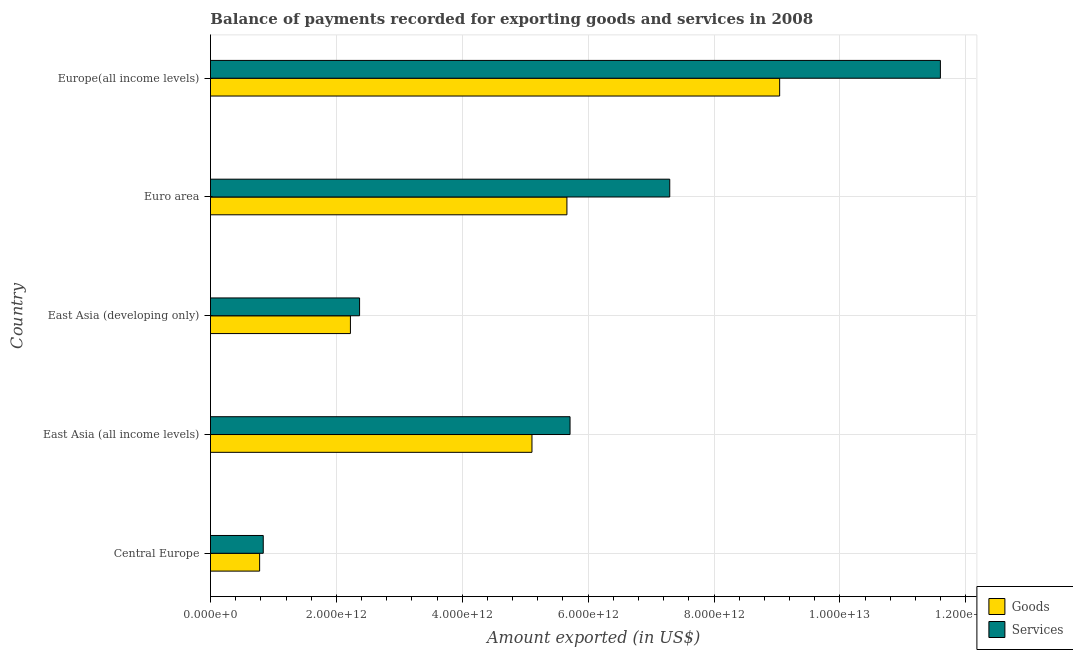How many different coloured bars are there?
Offer a very short reply. 2. Are the number of bars per tick equal to the number of legend labels?
Ensure brevity in your answer.  Yes. Are the number of bars on each tick of the Y-axis equal?
Ensure brevity in your answer.  Yes. How many bars are there on the 5th tick from the top?
Give a very brief answer. 2. How many bars are there on the 5th tick from the bottom?
Provide a short and direct response. 2. What is the label of the 3rd group of bars from the top?
Make the answer very short. East Asia (developing only). In how many cases, is the number of bars for a given country not equal to the number of legend labels?
Provide a short and direct response. 0. What is the amount of goods exported in Central Europe?
Your answer should be compact. 7.81e+11. Across all countries, what is the maximum amount of services exported?
Offer a very short reply. 1.16e+13. Across all countries, what is the minimum amount of services exported?
Offer a very short reply. 8.38e+11. In which country was the amount of goods exported maximum?
Offer a terse response. Europe(all income levels). In which country was the amount of goods exported minimum?
Give a very brief answer. Central Europe. What is the total amount of goods exported in the graph?
Offer a terse response. 2.28e+13. What is the difference between the amount of goods exported in East Asia (all income levels) and that in Euro area?
Keep it short and to the point. -5.55e+11. What is the difference between the amount of services exported in East Asia (all income levels) and the amount of goods exported in East Asia (developing only)?
Provide a short and direct response. 3.49e+12. What is the average amount of goods exported per country?
Provide a succinct answer. 4.56e+12. What is the difference between the amount of goods exported and amount of services exported in East Asia (all income levels)?
Offer a very short reply. -6.05e+11. What is the ratio of the amount of services exported in Central Europe to that in East Asia (all income levels)?
Make the answer very short. 0.15. Is the amount of goods exported in East Asia (developing only) less than that in Europe(all income levels)?
Keep it short and to the point. Yes. Is the difference between the amount of services exported in Central Europe and East Asia (developing only) greater than the difference between the amount of goods exported in Central Europe and East Asia (developing only)?
Your answer should be compact. No. What is the difference between the highest and the second highest amount of services exported?
Your answer should be very brief. 4.30e+12. What is the difference between the highest and the lowest amount of services exported?
Your answer should be compact. 1.08e+13. Is the sum of the amount of goods exported in East Asia (developing only) and Europe(all income levels) greater than the maximum amount of services exported across all countries?
Your answer should be very brief. No. What does the 1st bar from the top in Euro area represents?
Provide a short and direct response. Services. What does the 1st bar from the bottom in East Asia (all income levels) represents?
Offer a terse response. Goods. How many countries are there in the graph?
Your response must be concise. 5. What is the difference between two consecutive major ticks on the X-axis?
Offer a terse response. 2.00e+12. Does the graph contain grids?
Provide a succinct answer. Yes. How are the legend labels stacked?
Give a very brief answer. Vertical. What is the title of the graph?
Your response must be concise. Balance of payments recorded for exporting goods and services in 2008. Does "Methane emissions" appear as one of the legend labels in the graph?
Your response must be concise. No. What is the label or title of the X-axis?
Offer a very short reply. Amount exported (in US$). What is the Amount exported (in US$) in Goods in Central Europe?
Keep it short and to the point. 7.81e+11. What is the Amount exported (in US$) in Services in Central Europe?
Offer a terse response. 8.38e+11. What is the Amount exported (in US$) in Goods in East Asia (all income levels)?
Keep it short and to the point. 5.11e+12. What is the Amount exported (in US$) in Services in East Asia (all income levels)?
Your answer should be very brief. 5.71e+12. What is the Amount exported (in US$) in Goods in East Asia (developing only)?
Keep it short and to the point. 2.22e+12. What is the Amount exported (in US$) in Services in East Asia (developing only)?
Offer a terse response. 2.37e+12. What is the Amount exported (in US$) in Goods in Euro area?
Your answer should be very brief. 5.66e+12. What is the Amount exported (in US$) of Services in Euro area?
Offer a very short reply. 7.30e+12. What is the Amount exported (in US$) of Goods in Europe(all income levels)?
Your response must be concise. 9.04e+12. What is the Amount exported (in US$) of Services in Europe(all income levels)?
Make the answer very short. 1.16e+13. Across all countries, what is the maximum Amount exported (in US$) in Goods?
Ensure brevity in your answer.  9.04e+12. Across all countries, what is the maximum Amount exported (in US$) in Services?
Keep it short and to the point. 1.16e+13. Across all countries, what is the minimum Amount exported (in US$) in Goods?
Ensure brevity in your answer.  7.81e+11. Across all countries, what is the minimum Amount exported (in US$) of Services?
Keep it short and to the point. 8.38e+11. What is the total Amount exported (in US$) in Goods in the graph?
Make the answer very short. 2.28e+13. What is the total Amount exported (in US$) of Services in the graph?
Provide a succinct answer. 2.78e+13. What is the difference between the Amount exported (in US$) in Goods in Central Europe and that in East Asia (all income levels)?
Ensure brevity in your answer.  -4.33e+12. What is the difference between the Amount exported (in US$) of Services in Central Europe and that in East Asia (all income levels)?
Provide a short and direct response. -4.87e+12. What is the difference between the Amount exported (in US$) of Goods in Central Europe and that in East Asia (developing only)?
Ensure brevity in your answer.  -1.44e+12. What is the difference between the Amount exported (in US$) in Services in Central Europe and that in East Asia (developing only)?
Provide a short and direct response. -1.53e+12. What is the difference between the Amount exported (in US$) in Goods in Central Europe and that in Euro area?
Keep it short and to the point. -4.88e+12. What is the difference between the Amount exported (in US$) of Services in Central Europe and that in Euro area?
Offer a terse response. -6.46e+12. What is the difference between the Amount exported (in US$) of Goods in Central Europe and that in Europe(all income levels)?
Ensure brevity in your answer.  -8.26e+12. What is the difference between the Amount exported (in US$) of Services in Central Europe and that in Europe(all income levels)?
Offer a terse response. -1.08e+13. What is the difference between the Amount exported (in US$) in Goods in East Asia (all income levels) and that in East Asia (developing only)?
Make the answer very short. 2.88e+12. What is the difference between the Amount exported (in US$) of Services in East Asia (all income levels) and that in East Asia (developing only)?
Offer a terse response. 3.34e+12. What is the difference between the Amount exported (in US$) of Goods in East Asia (all income levels) and that in Euro area?
Keep it short and to the point. -5.55e+11. What is the difference between the Amount exported (in US$) of Services in East Asia (all income levels) and that in Euro area?
Keep it short and to the point. -1.58e+12. What is the difference between the Amount exported (in US$) of Goods in East Asia (all income levels) and that in Europe(all income levels)?
Your response must be concise. -3.94e+12. What is the difference between the Amount exported (in US$) of Services in East Asia (all income levels) and that in Europe(all income levels)?
Make the answer very short. -5.88e+12. What is the difference between the Amount exported (in US$) in Goods in East Asia (developing only) and that in Euro area?
Offer a terse response. -3.44e+12. What is the difference between the Amount exported (in US$) of Services in East Asia (developing only) and that in Euro area?
Ensure brevity in your answer.  -4.93e+12. What is the difference between the Amount exported (in US$) of Goods in East Asia (developing only) and that in Europe(all income levels)?
Your response must be concise. -6.82e+12. What is the difference between the Amount exported (in US$) in Services in East Asia (developing only) and that in Europe(all income levels)?
Your answer should be compact. -9.23e+12. What is the difference between the Amount exported (in US$) in Goods in Euro area and that in Europe(all income levels)?
Make the answer very short. -3.38e+12. What is the difference between the Amount exported (in US$) in Services in Euro area and that in Europe(all income levels)?
Ensure brevity in your answer.  -4.30e+12. What is the difference between the Amount exported (in US$) in Goods in Central Europe and the Amount exported (in US$) in Services in East Asia (all income levels)?
Offer a very short reply. -4.93e+12. What is the difference between the Amount exported (in US$) in Goods in Central Europe and the Amount exported (in US$) in Services in East Asia (developing only)?
Your response must be concise. -1.59e+12. What is the difference between the Amount exported (in US$) in Goods in Central Europe and the Amount exported (in US$) in Services in Euro area?
Your answer should be very brief. -6.52e+12. What is the difference between the Amount exported (in US$) of Goods in Central Europe and the Amount exported (in US$) of Services in Europe(all income levels)?
Provide a short and direct response. -1.08e+13. What is the difference between the Amount exported (in US$) in Goods in East Asia (all income levels) and the Amount exported (in US$) in Services in East Asia (developing only)?
Your answer should be very brief. 2.74e+12. What is the difference between the Amount exported (in US$) in Goods in East Asia (all income levels) and the Amount exported (in US$) in Services in Euro area?
Your answer should be very brief. -2.19e+12. What is the difference between the Amount exported (in US$) in Goods in East Asia (all income levels) and the Amount exported (in US$) in Services in Europe(all income levels)?
Provide a short and direct response. -6.49e+12. What is the difference between the Amount exported (in US$) in Goods in East Asia (developing only) and the Amount exported (in US$) in Services in Euro area?
Make the answer very short. -5.07e+12. What is the difference between the Amount exported (in US$) of Goods in East Asia (developing only) and the Amount exported (in US$) of Services in Europe(all income levels)?
Your answer should be compact. -9.37e+12. What is the difference between the Amount exported (in US$) of Goods in Euro area and the Amount exported (in US$) of Services in Europe(all income levels)?
Your answer should be very brief. -5.93e+12. What is the average Amount exported (in US$) in Goods per country?
Your response must be concise. 4.56e+12. What is the average Amount exported (in US$) in Services per country?
Your answer should be very brief. 5.56e+12. What is the difference between the Amount exported (in US$) of Goods and Amount exported (in US$) of Services in Central Europe?
Keep it short and to the point. -5.75e+1. What is the difference between the Amount exported (in US$) in Goods and Amount exported (in US$) in Services in East Asia (all income levels)?
Keep it short and to the point. -6.05e+11. What is the difference between the Amount exported (in US$) of Goods and Amount exported (in US$) of Services in East Asia (developing only)?
Provide a short and direct response. -1.45e+11. What is the difference between the Amount exported (in US$) of Goods and Amount exported (in US$) of Services in Euro area?
Ensure brevity in your answer.  -1.63e+12. What is the difference between the Amount exported (in US$) in Goods and Amount exported (in US$) in Services in Europe(all income levels)?
Offer a terse response. -2.55e+12. What is the ratio of the Amount exported (in US$) of Goods in Central Europe to that in East Asia (all income levels)?
Provide a short and direct response. 0.15. What is the ratio of the Amount exported (in US$) of Services in Central Europe to that in East Asia (all income levels)?
Offer a very short reply. 0.15. What is the ratio of the Amount exported (in US$) in Goods in Central Europe to that in East Asia (developing only)?
Provide a short and direct response. 0.35. What is the ratio of the Amount exported (in US$) of Services in Central Europe to that in East Asia (developing only)?
Offer a terse response. 0.35. What is the ratio of the Amount exported (in US$) in Goods in Central Europe to that in Euro area?
Make the answer very short. 0.14. What is the ratio of the Amount exported (in US$) in Services in Central Europe to that in Euro area?
Give a very brief answer. 0.11. What is the ratio of the Amount exported (in US$) in Goods in Central Europe to that in Europe(all income levels)?
Your answer should be very brief. 0.09. What is the ratio of the Amount exported (in US$) of Services in Central Europe to that in Europe(all income levels)?
Your response must be concise. 0.07. What is the ratio of the Amount exported (in US$) in Goods in East Asia (all income levels) to that in East Asia (developing only)?
Your response must be concise. 2.3. What is the ratio of the Amount exported (in US$) of Services in East Asia (all income levels) to that in East Asia (developing only)?
Provide a short and direct response. 2.41. What is the ratio of the Amount exported (in US$) in Goods in East Asia (all income levels) to that in Euro area?
Ensure brevity in your answer.  0.9. What is the ratio of the Amount exported (in US$) of Services in East Asia (all income levels) to that in Euro area?
Your response must be concise. 0.78. What is the ratio of the Amount exported (in US$) of Goods in East Asia (all income levels) to that in Europe(all income levels)?
Offer a terse response. 0.56. What is the ratio of the Amount exported (in US$) of Services in East Asia (all income levels) to that in Europe(all income levels)?
Provide a short and direct response. 0.49. What is the ratio of the Amount exported (in US$) of Goods in East Asia (developing only) to that in Euro area?
Offer a terse response. 0.39. What is the ratio of the Amount exported (in US$) of Services in East Asia (developing only) to that in Euro area?
Provide a succinct answer. 0.32. What is the ratio of the Amount exported (in US$) in Goods in East Asia (developing only) to that in Europe(all income levels)?
Provide a succinct answer. 0.25. What is the ratio of the Amount exported (in US$) of Services in East Asia (developing only) to that in Europe(all income levels)?
Offer a terse response. 0.2. What is the ratio of the Amount exported (in US$) of Goods in Euro area to that in Europe(all income levels)?
Make the answer very short. 0.63. What is the ratio of the Amount exported (in US$) in Services in Euro area to that in Europe(all income levels)?
Ensure brevity in your answer.  0.63. What is the difference between the highest and the second highest Amount exported (in US$) in Goods?
Offer a very short reply. 3.38e+12. What is the difference between the highest and the second highest Amount exported (in US$) of Services?
Offer a very short reply. 4.30e+12. What is the difference between the highest and the lowest Amount exported (in US$) in Goods?
Offer a very short reply. 8.26e+12. What is the difference between the highest and the lowest Amount exported (in US$) in Services?
Offer a very short reply. 1.08e+13. 